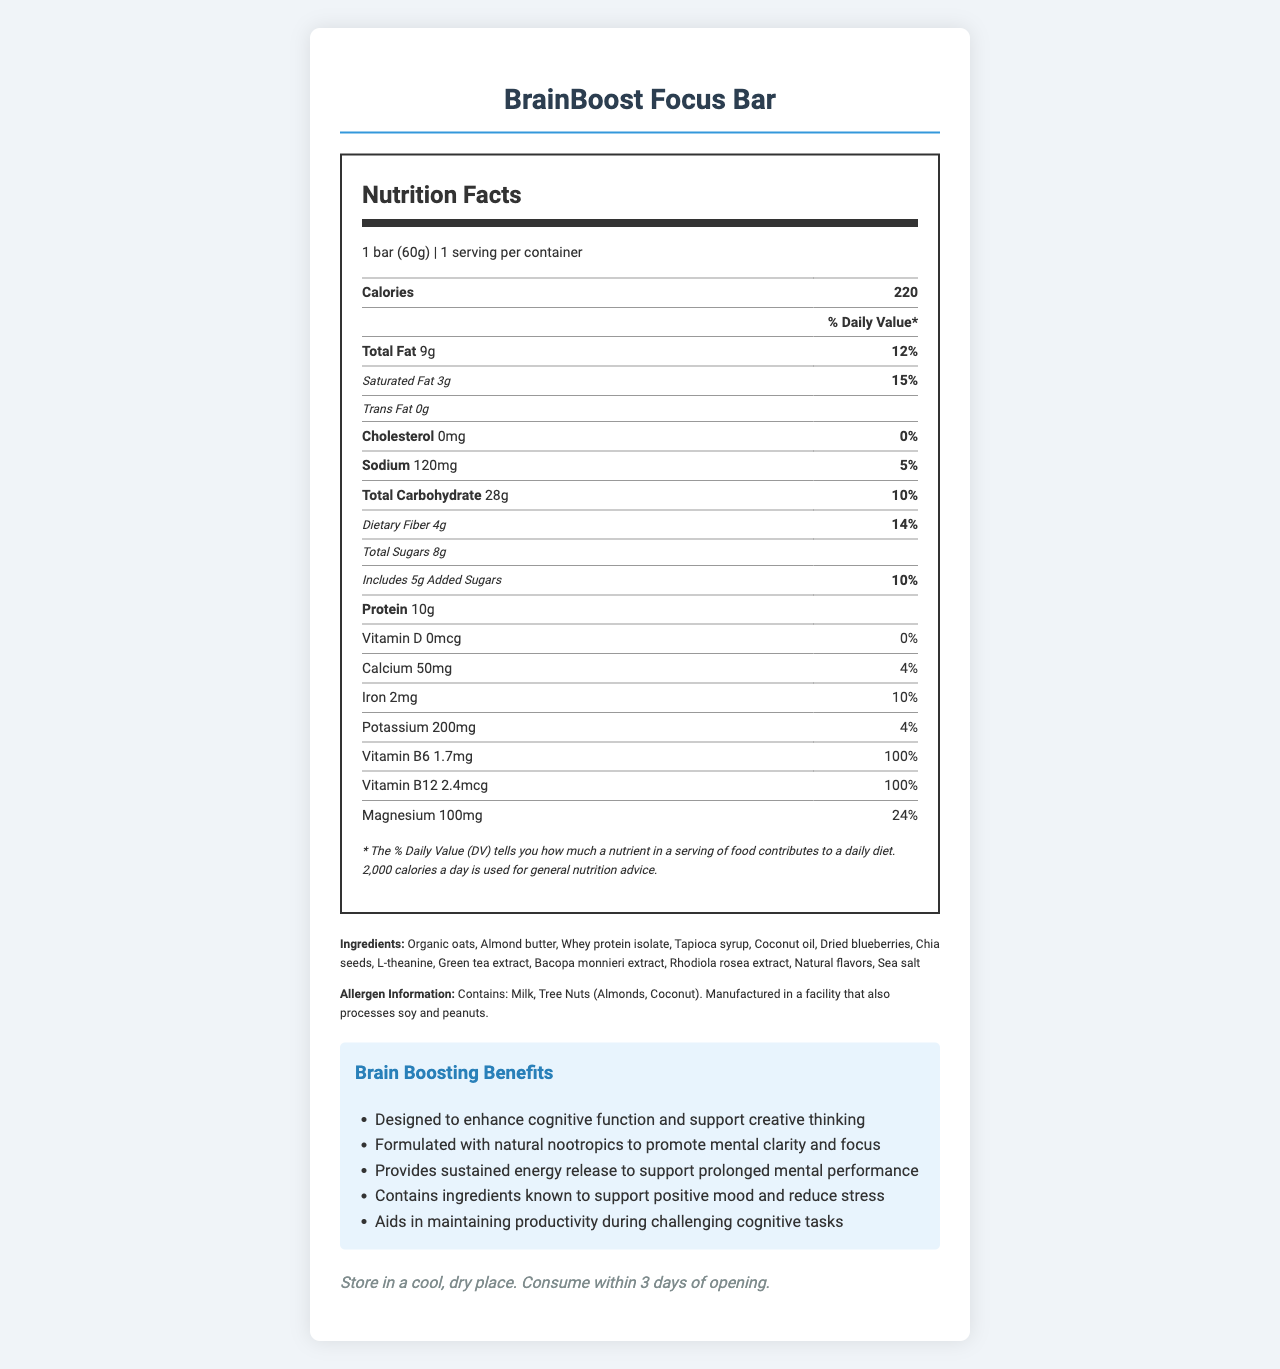what is the serving size for the BrainBoost Focus Bar? The serving size is clearly mentioned at the top of the nutrition label portion of the document.
Answer: 1 bar (60g) how many calories are in one serving of the BrainBoost Focus Bar? The number of calories per serving is listed near the top of the nutrition label.
Answer: 220 what is the amount of protein in one serving of the BrainBoost Focus Bar? The protein content is listed in the nutrition label towards the middle section.
Answer: 10g what are the ingredients of the BrainBoost Focus Bar? The list of ingredients is located towards the bottom under the "Ingredients" section.
Answer: Organic oats, Almond butter, Whey protein isolate, Tapioca syrup, Coconut oil, Dried blueberries, Chia seeds, L-theanine, Green tea extract, Bacopa monnieri extract, Rhodiola rosea extract, Natural flavors, Sea salt list two brain-boosting claims mentioned for the BrainBoost Focus Bar. These claims are located under the "Brain Boosting Benefits" section.
Answer: Designed to enhance cognitive function and support creative thinking, Formulated with natural nootropics to promote mental clarity and focus how much Vitamin B6 does the BrainBoost Focus Bar contain? A. 1.7mg B. 10mg C. 0.5mg This information is included in the nutrition label under the vitamins and minerals section.
Answer: A. 1.7mg how much cholesterol does the BrainBoost Focus Bar contain? A. 5mg B. 0mg C. 10mg D. 20mg The cholesterol amount is listed as 0mg in the nutrition label.
Answer: B. 0mg does the BrainBoost Focus Bar contain soy? According to the allergen information, it is manufactured in a facility that processes soy, but it does not contain soy as an ingredient.
Answer: No what daily value percentage of magnesium does the BrainBoost Focus Bar provide? This information can be found in the nutrition label under the vitamins and minerals section.
Answer: 24% summarize the key features of the BrainBoost Focus Bar. This summary is based on multiple sections of the document including the nutrition label, ingredients list, benefits claims, and additional information.
Answer: The BrainBoost Focus Bar is an energy bar designed to enhance cognitive function and support creative thinking. It contains natural nootropics like L-theanine, green tea extract, Bacopa monnieri extract, and Rhodiola rosea extract. It provides sustained energy release and supports mental clarity, positive mood, and productivity. The bar is made with ingredients like organic oats, almond butter, and whey protein isolate. Each bar has 220 calories, 9g of total fat, 10g of protein, and important vitamins and minerals. It is free from cholesterol and contains 4g of dietary fiber. what is the recommended storage instruction for the BrainBoost Focus Bar? This information is provided at the bottom of the document under the storage instructions section.
Answer: Store in a cool, dry place. Consume within 3 days of opening. how much caffeine is in the BrainBoost Focus Bar? The amount of caffeine is located near the end of the nutrition label, below the vitamins and minerals section.
Answer: 75mg is this bar suitable for people with peanut allergies? The bar is manufactured in a facility that also processes peanuts, which might be a risk for people with peanut allergies.
Answer: Cannot be determined how many grams of sustained-release carbohydrates does the BrainBoost Focus Bar contain? The amount of sustained-release carbohydrates is specifically stated at the end of the nutrition label.
Answer: 15g 